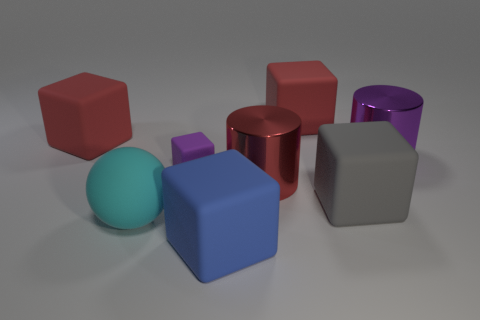Subtract all red blocks. How many were subtracted if there are1red blocks left? 1 Subtract all large blocks. How many blocks are left? 1 Add 2 small rubber objects. How many objects exist? 10 Subtract all purple cylinders. How many cylinders are left? 1 Add 6 large purple metal cylinders. How many large purple metal cylinders are left? 7 Add 5 purple matte cubes. How many purple matte cubes exist? 6 Subtract 0 brown spheres. How many objects are left? 8 Subtract all cubes. How many objects are left? 3 Subtract 2 cubes. How many cubes are left? 3 Subtract all red cylinders. Subtract all blue balls. How many cylinders are left? 1 